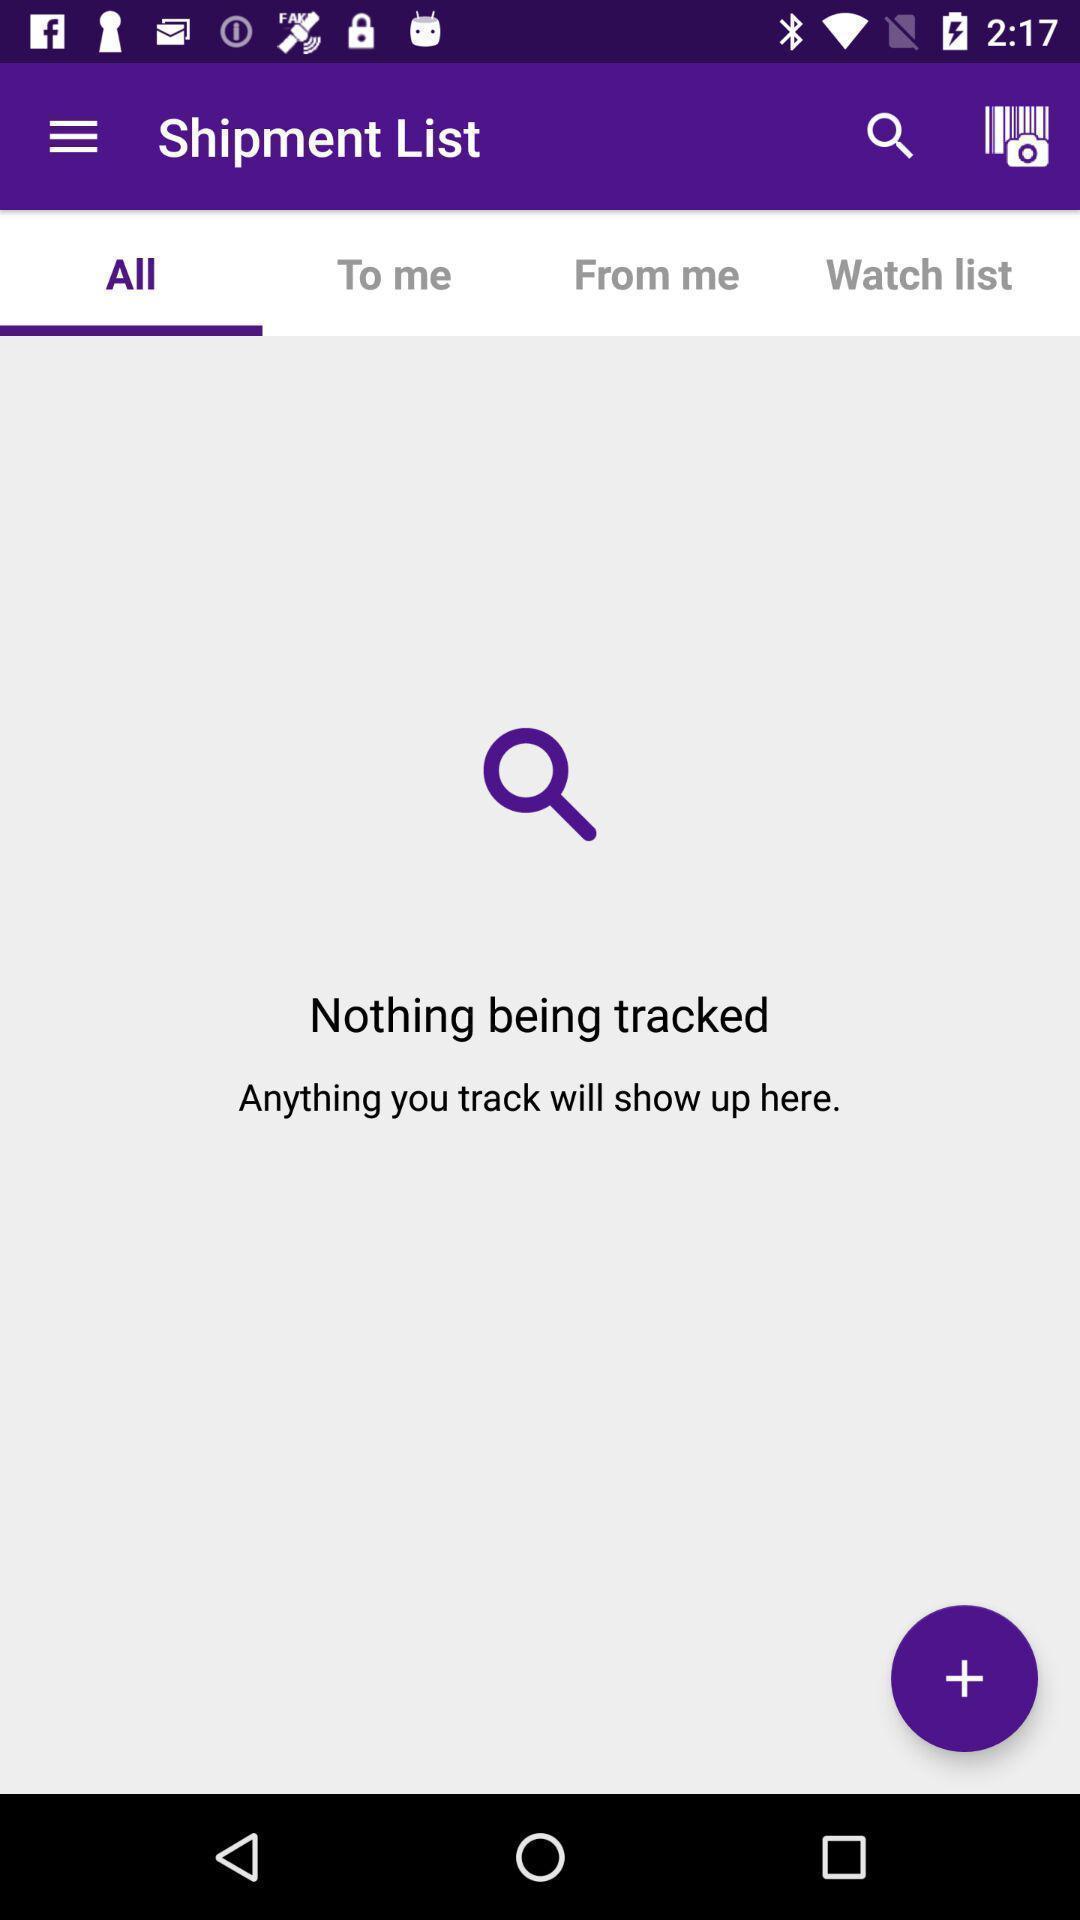What is the overall content of this screenshot? Page showing your shipment list. 